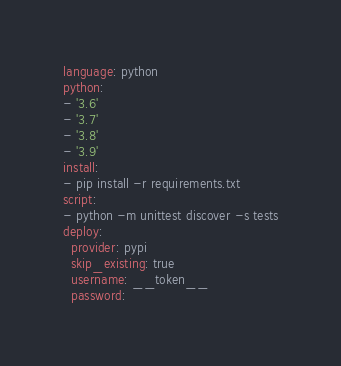Convert code to text. <code><loc_0><loc_0><loc_500><loc_500><_YAML_>language: python
python:
- '3.6'
- '3.7'
- '3.8'
- '3.9'
install:
- pip install -r requirements.txt
script:
- python -m unittest discover -s tests
deploy:
  provider: pypi
  skip_existing: true
  username: __token__
  password:</code> 